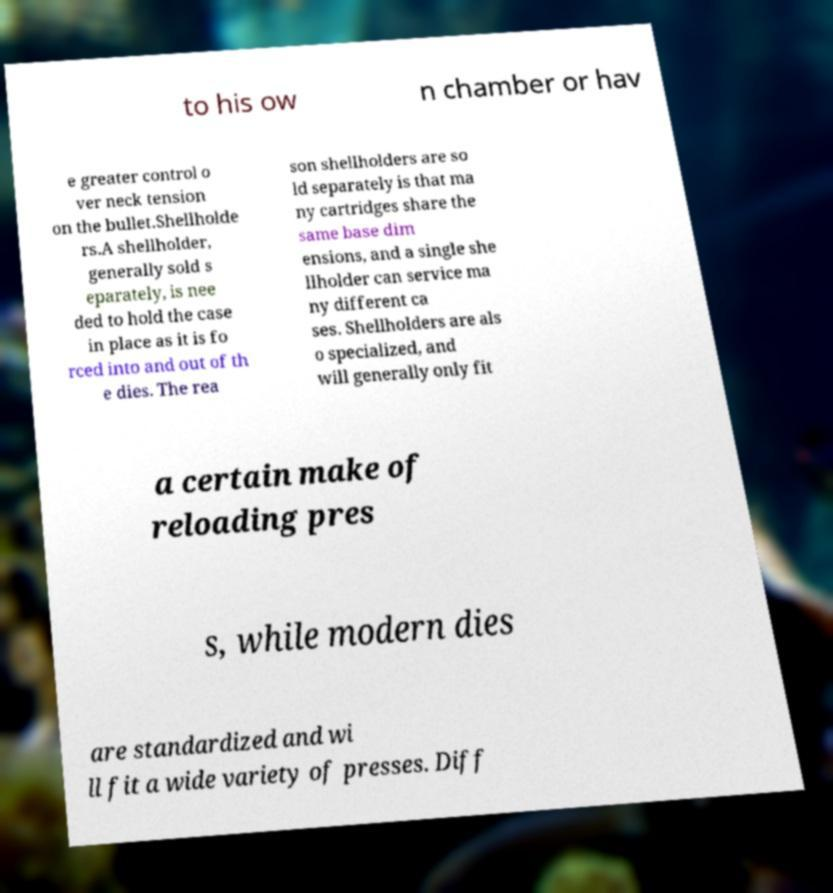For documentation purposes, I need the text within this image transcribed. Could you provide that? to his ow n chamber or hav e greater control o ver neck tension on the bullet.Shellholde rs.A shellholder, generally sold s eparately, is nee ded to hold the case in place as it is fo rced into and out of th e dies. The rea son shellholders are so ld separately is that ma ny cartridges share the same base dim ensions, and a single she llholder can service ma ny different ca ses. Shellholders are als o specialized, and will generally only fit a certain make of reloading pres s, while modern dies are standardized and wi ll fit a wide variety of presses. Diff 